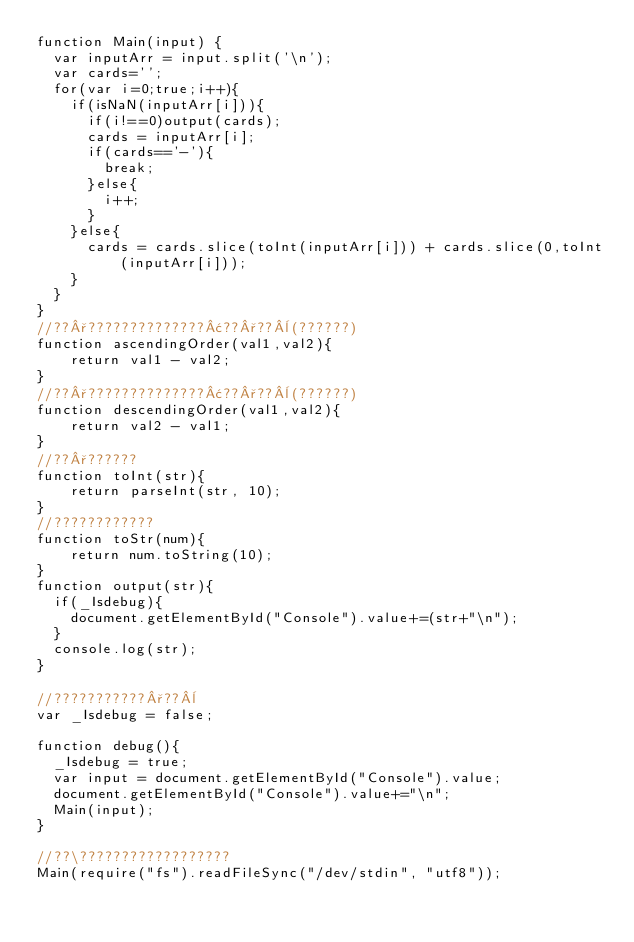Convert code to text. <code><loc_0><loc_0><loc_500><loc_500><_JavaScript_>function Main(input) {
	var inputArr = input.split('\n');
	var cards='';
	for(var i=0;true;i++){
		if(isNaN(inputArr[i])){
			if(i!==0)output(cards);
			cards = inputArr[i];
			if(cards=='-'){
				break;
			}else{
				i++;
			}
		}else{
			cards = cards.slice(toInt(inputArr[i])) + cards.slice(0,toInt(inputArr[i]));
		}
	}
}
//??°??????????????¢??°??¨(??????)
function ascendingOrder(val1,val2){
    return val1 - val2;
}
//??°??????????????¢??°??¨(??????)
function descendingOrder(val1,val2){
    return val2 - val1;
}
//??°??????
function toInt(str){
    return parseInt(str, 10);
}
//????????????
function toStr(num){
    return num.toString(10);
}
function output(str){
	if(_Isdebug){
		document.getElementById("Console").value+=(str+"\n");
	}
	console.log(str);
}

//???????????°??¨
var _Isdebug = false;

function debug(){
	_Isdebug = true;
	var input = document.getElementById("Console").value;
	document.getElementById("Console").value+="\n";
	Main(input);
}

//??\??????????????????
Main(require("fs").readFileSync("/dev/stdin", "utf8"));</code> 